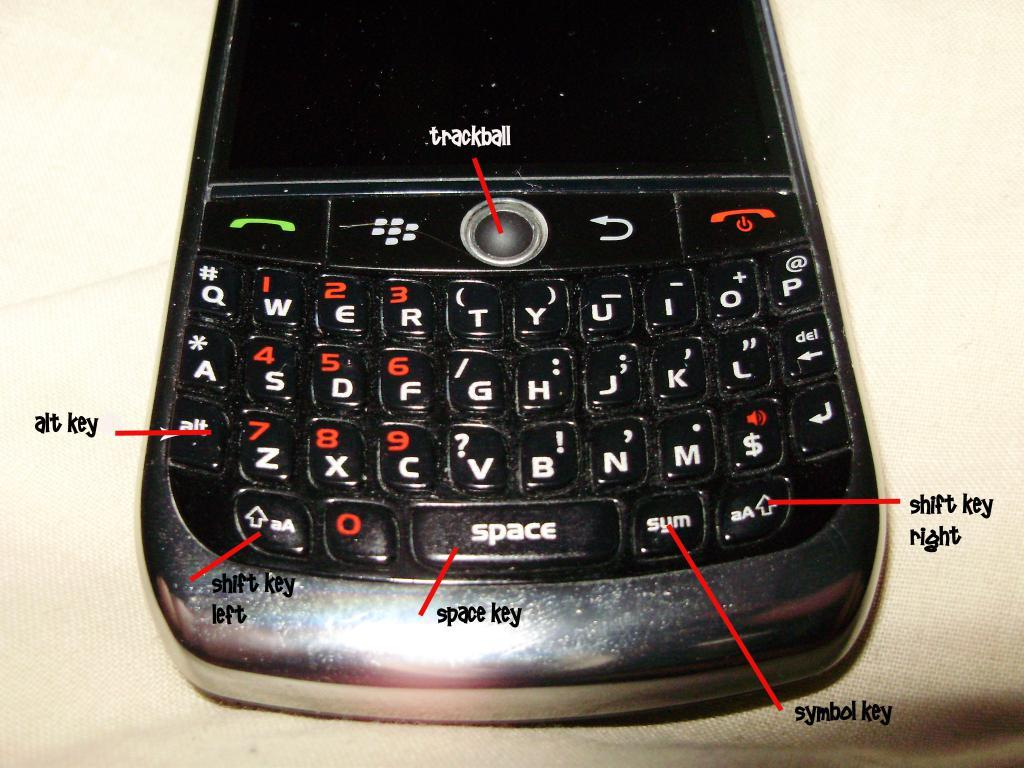<image>
Create a compact narrative representing the image presented. a phone that has a diagram that shows where the trackball is 